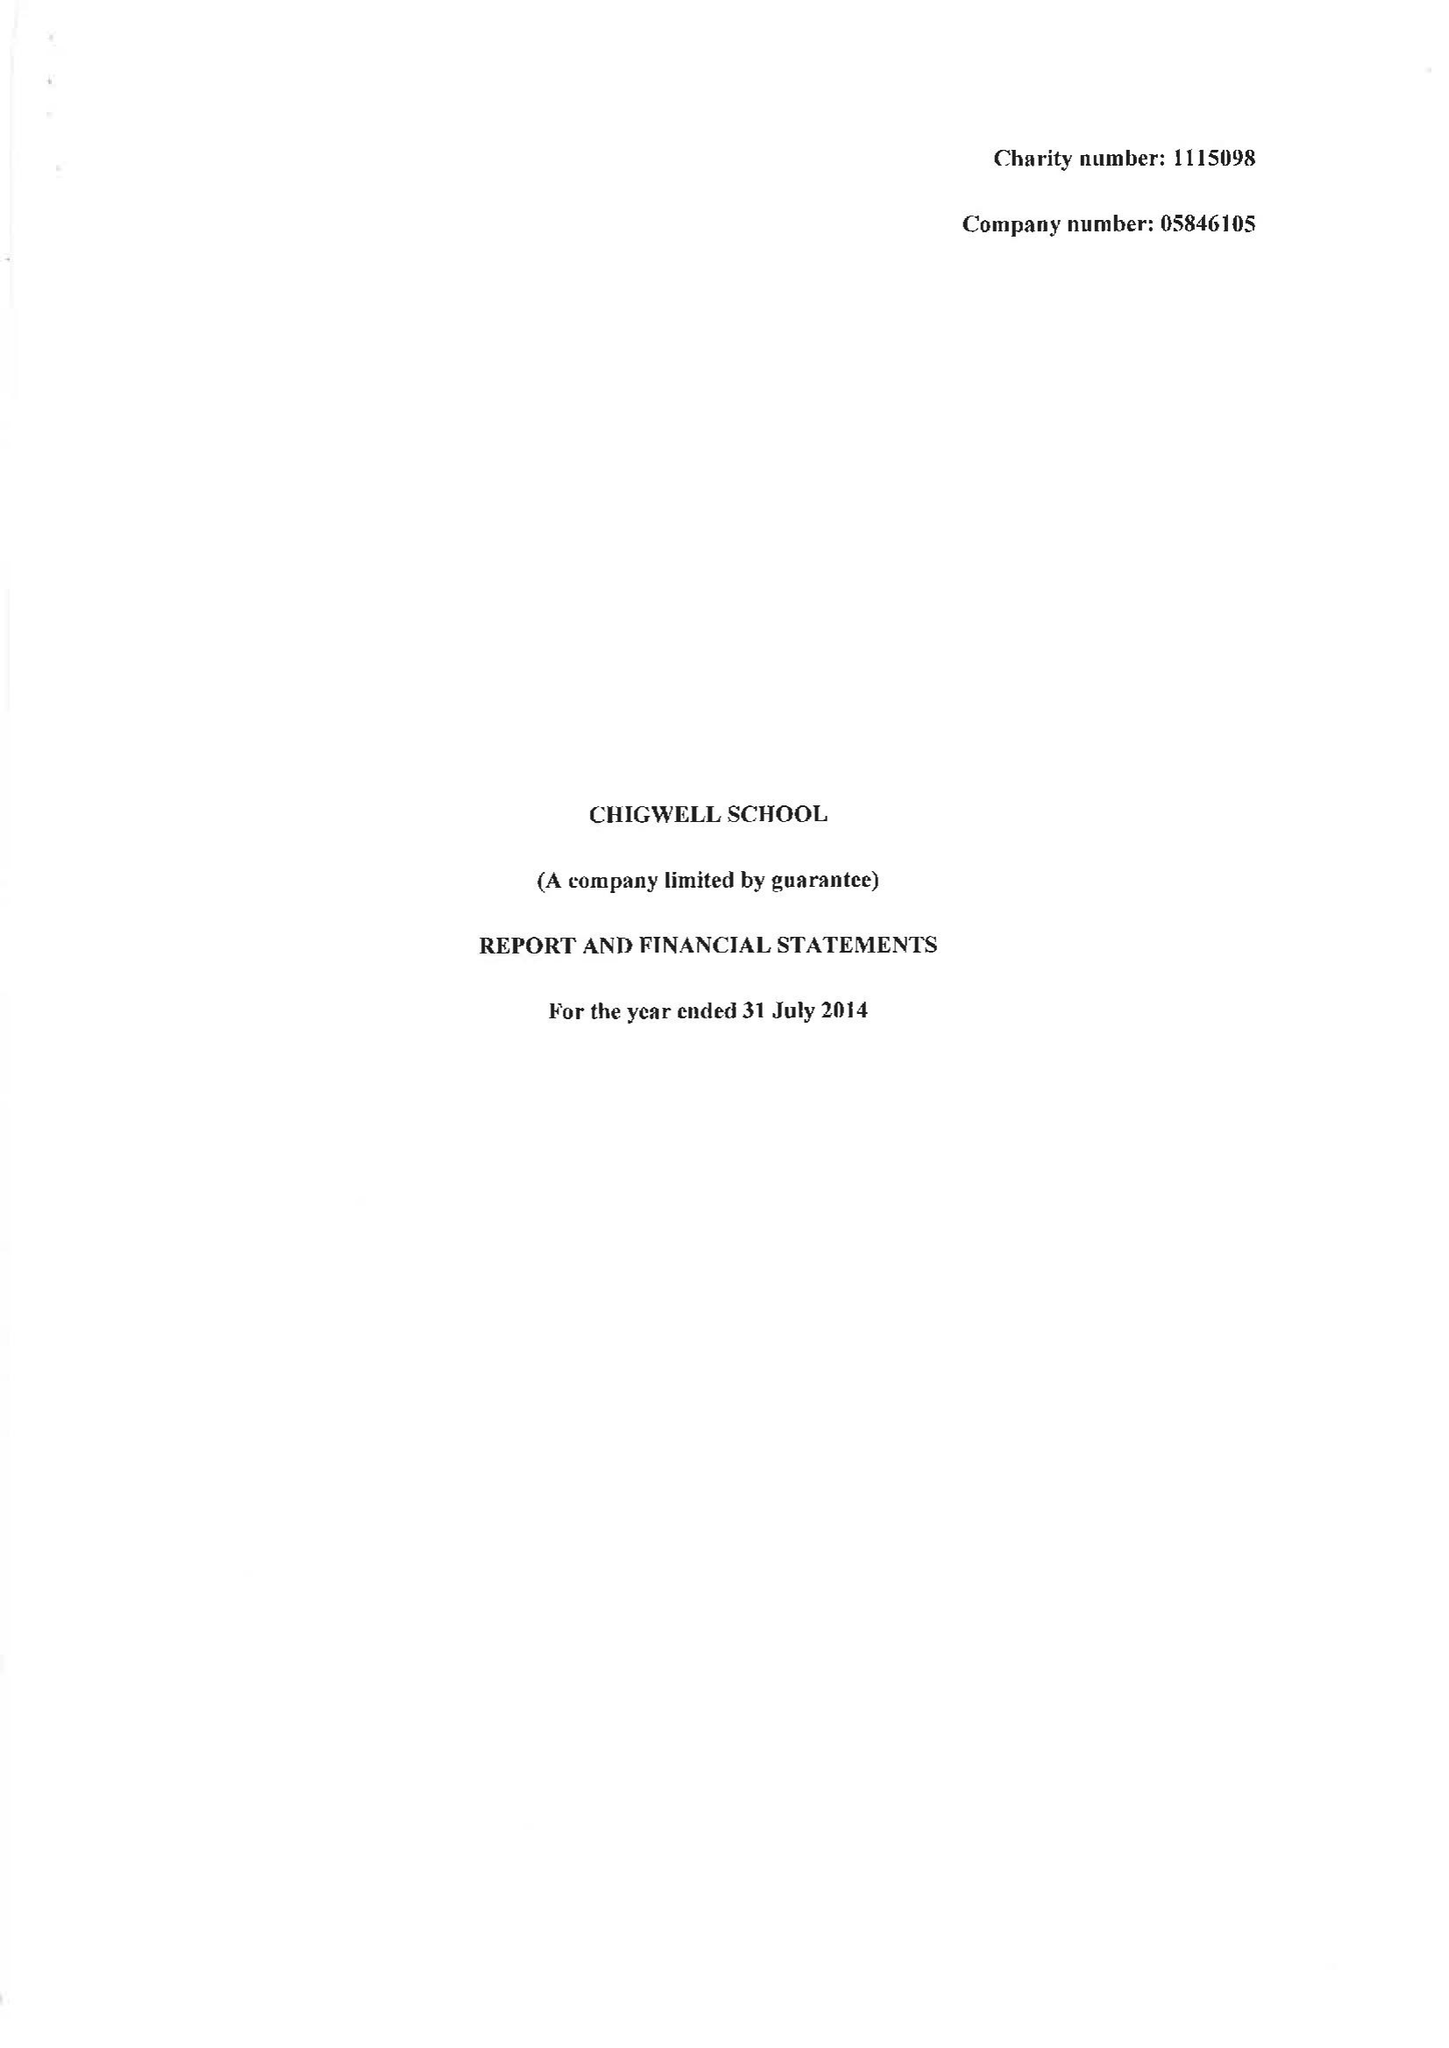What is the value for the address__post_town?
Answer the question using a single word or phrase. CHIGWELL 